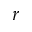<formula> <loc_0><loc_0><loc_500><loc_500>r</formula> 